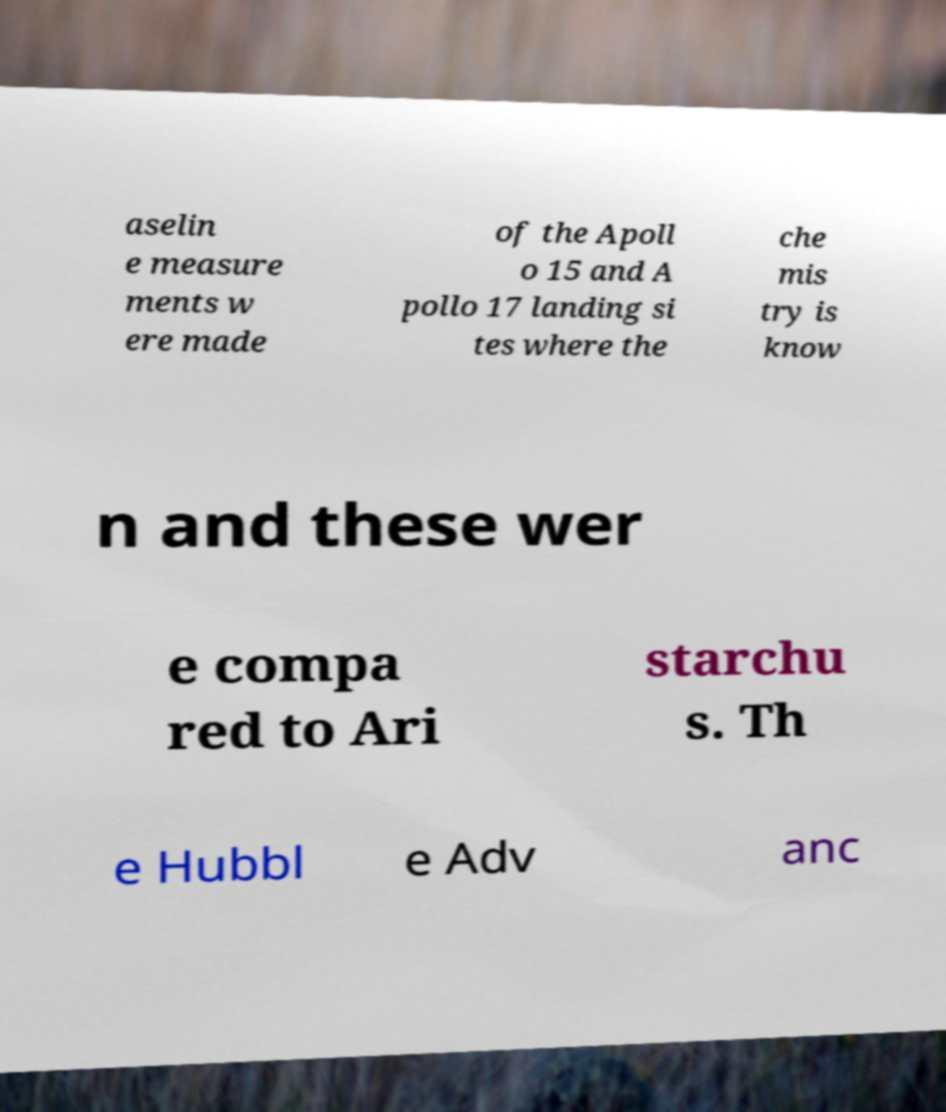For documentation purposes, I need the text within this image transcribed. Could you provide that? aselin e measure ments w ere made of the Apoll o 15 and A pollo 17 landing si tes where the che mis try is know n and these wer e compa red to Ari starchu s. Th e Hubbl e Adv anc 